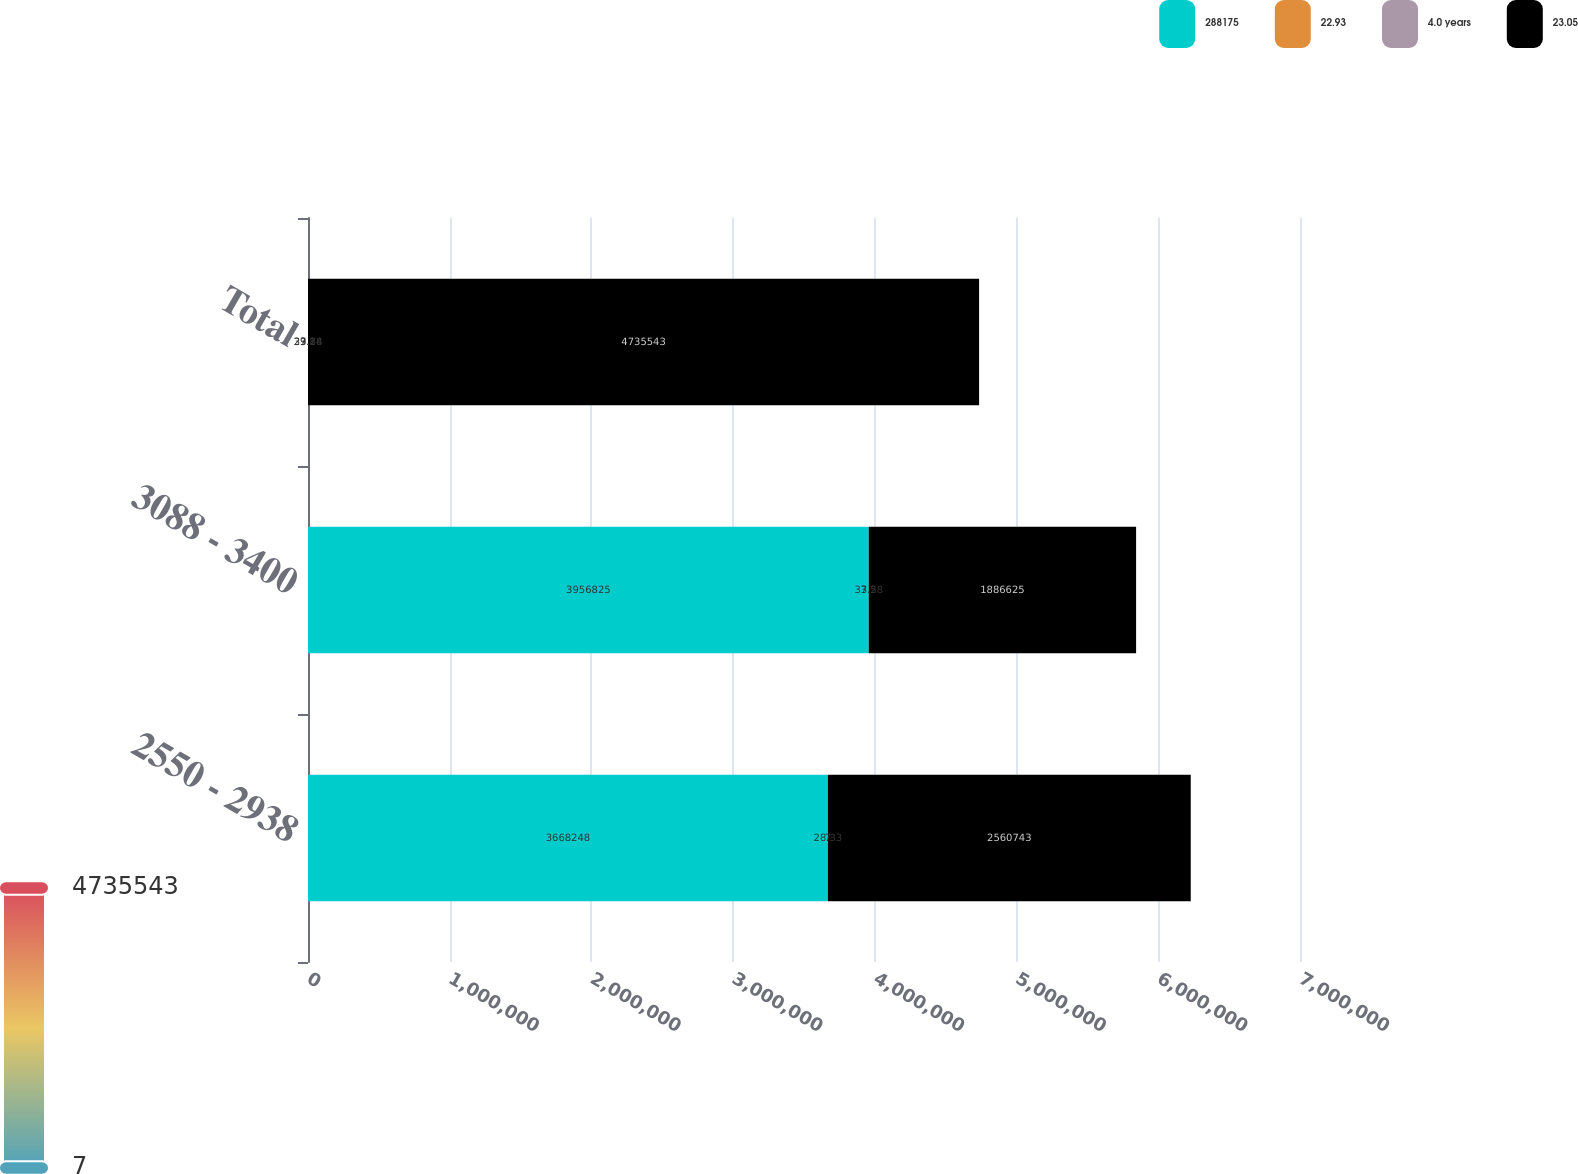<chart> <loc_0><loc_0><loc_500><loc_500><stacked_bar_chart><ecel><fcel>2550 - 2938<fcel>3088 - 3400<fcel>Total<nl><fcel>288175<fcel>3.66825e+06<fcel>3.95682e+06<fcel>33.28<nl><fcel>22.93<fcel>7<fcel>7.5<fcel>7.1<nl><fcel>4.0 years<fcel>28.33<fcel>33.28<fcel>29.84<nl><fcel>23.05<fcel>2.56074e+06<fcel>1.88662e+06<fcel>4.73554e+06<nl></chart> 